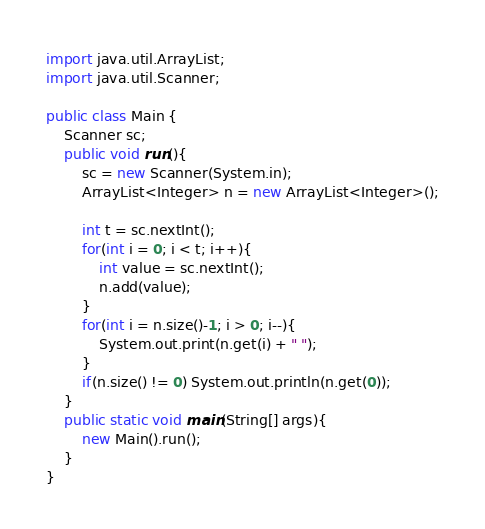Convert code to text. <code><loc_0><loc_0><loc_500><loc_500><_Java_>import java.util.ArrayList;
import java.util.Scanner;

public class Main {
	Scanner sc;
	public void run(){
		sc = new Scanner(System.in);
		ArrayList<Integer> n = new ArrayList<Integer>();
		
		int t = sc.nextInt();
		for(int i = 0; i < t; i++){
			int value = sc.nextInt();
			n.add(value);
		}
		for(int i = n.size()-1; i > 0; i--){
			System.out.print(n.get(i) + " ");
		}
		if(n.size() != 0) System.out.println(n.get(0));
	}
	public static void main(String[] args){
		new Main().run();
	}
}</code> 